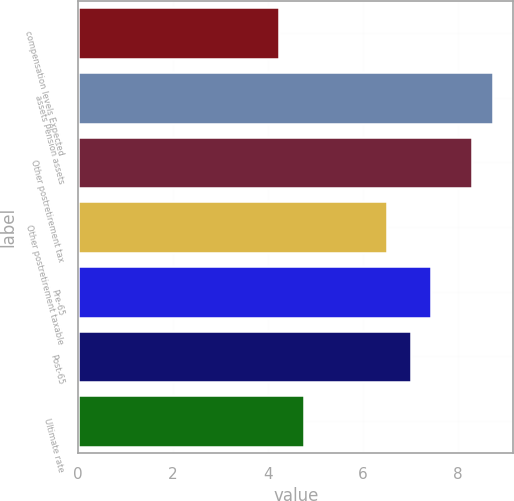Convert chart. <chart><loc_0><loc_0><loc_500><loc_500><bar_chart><fcel>compensation levels Expected<fcel>assets Pension assets<fcel>Other postretirement tax<fcel>Other postretirement taxable<fcel>Pre-65<fcel>Post-65<fcel>Ultimate rate<nl><fcel>4.23<fcel>8.73<fcel>8.3<fcel>6.5<fcel>7.43<fcel>7<fcel>4.75<nl></chart> 